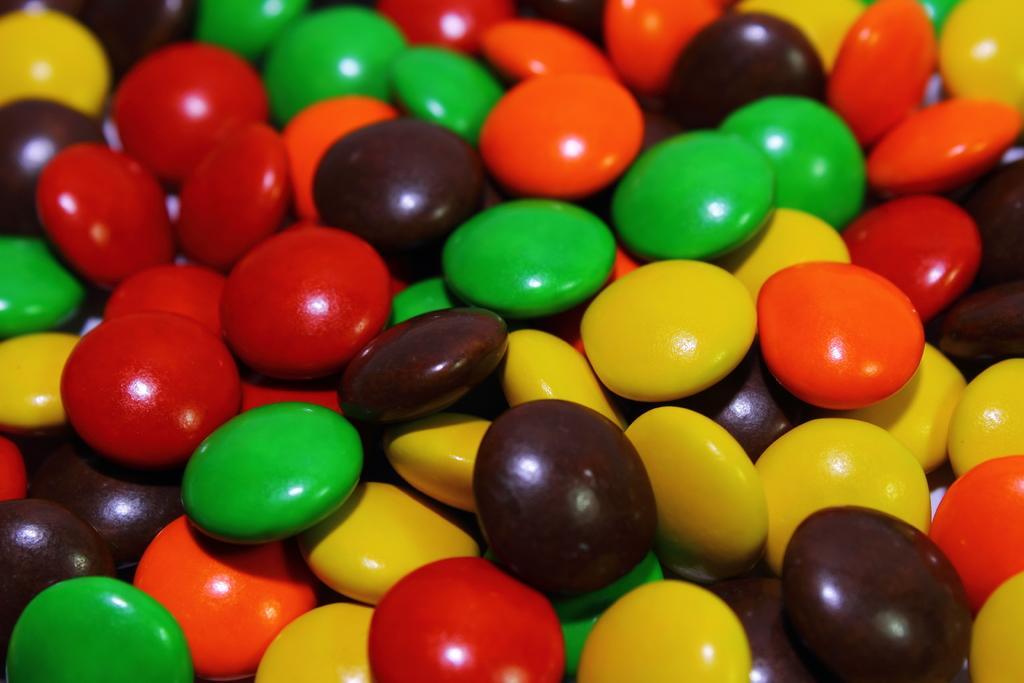How would you summarize this image in a sentence or two? In this image there are different colored chocolate buttons. 